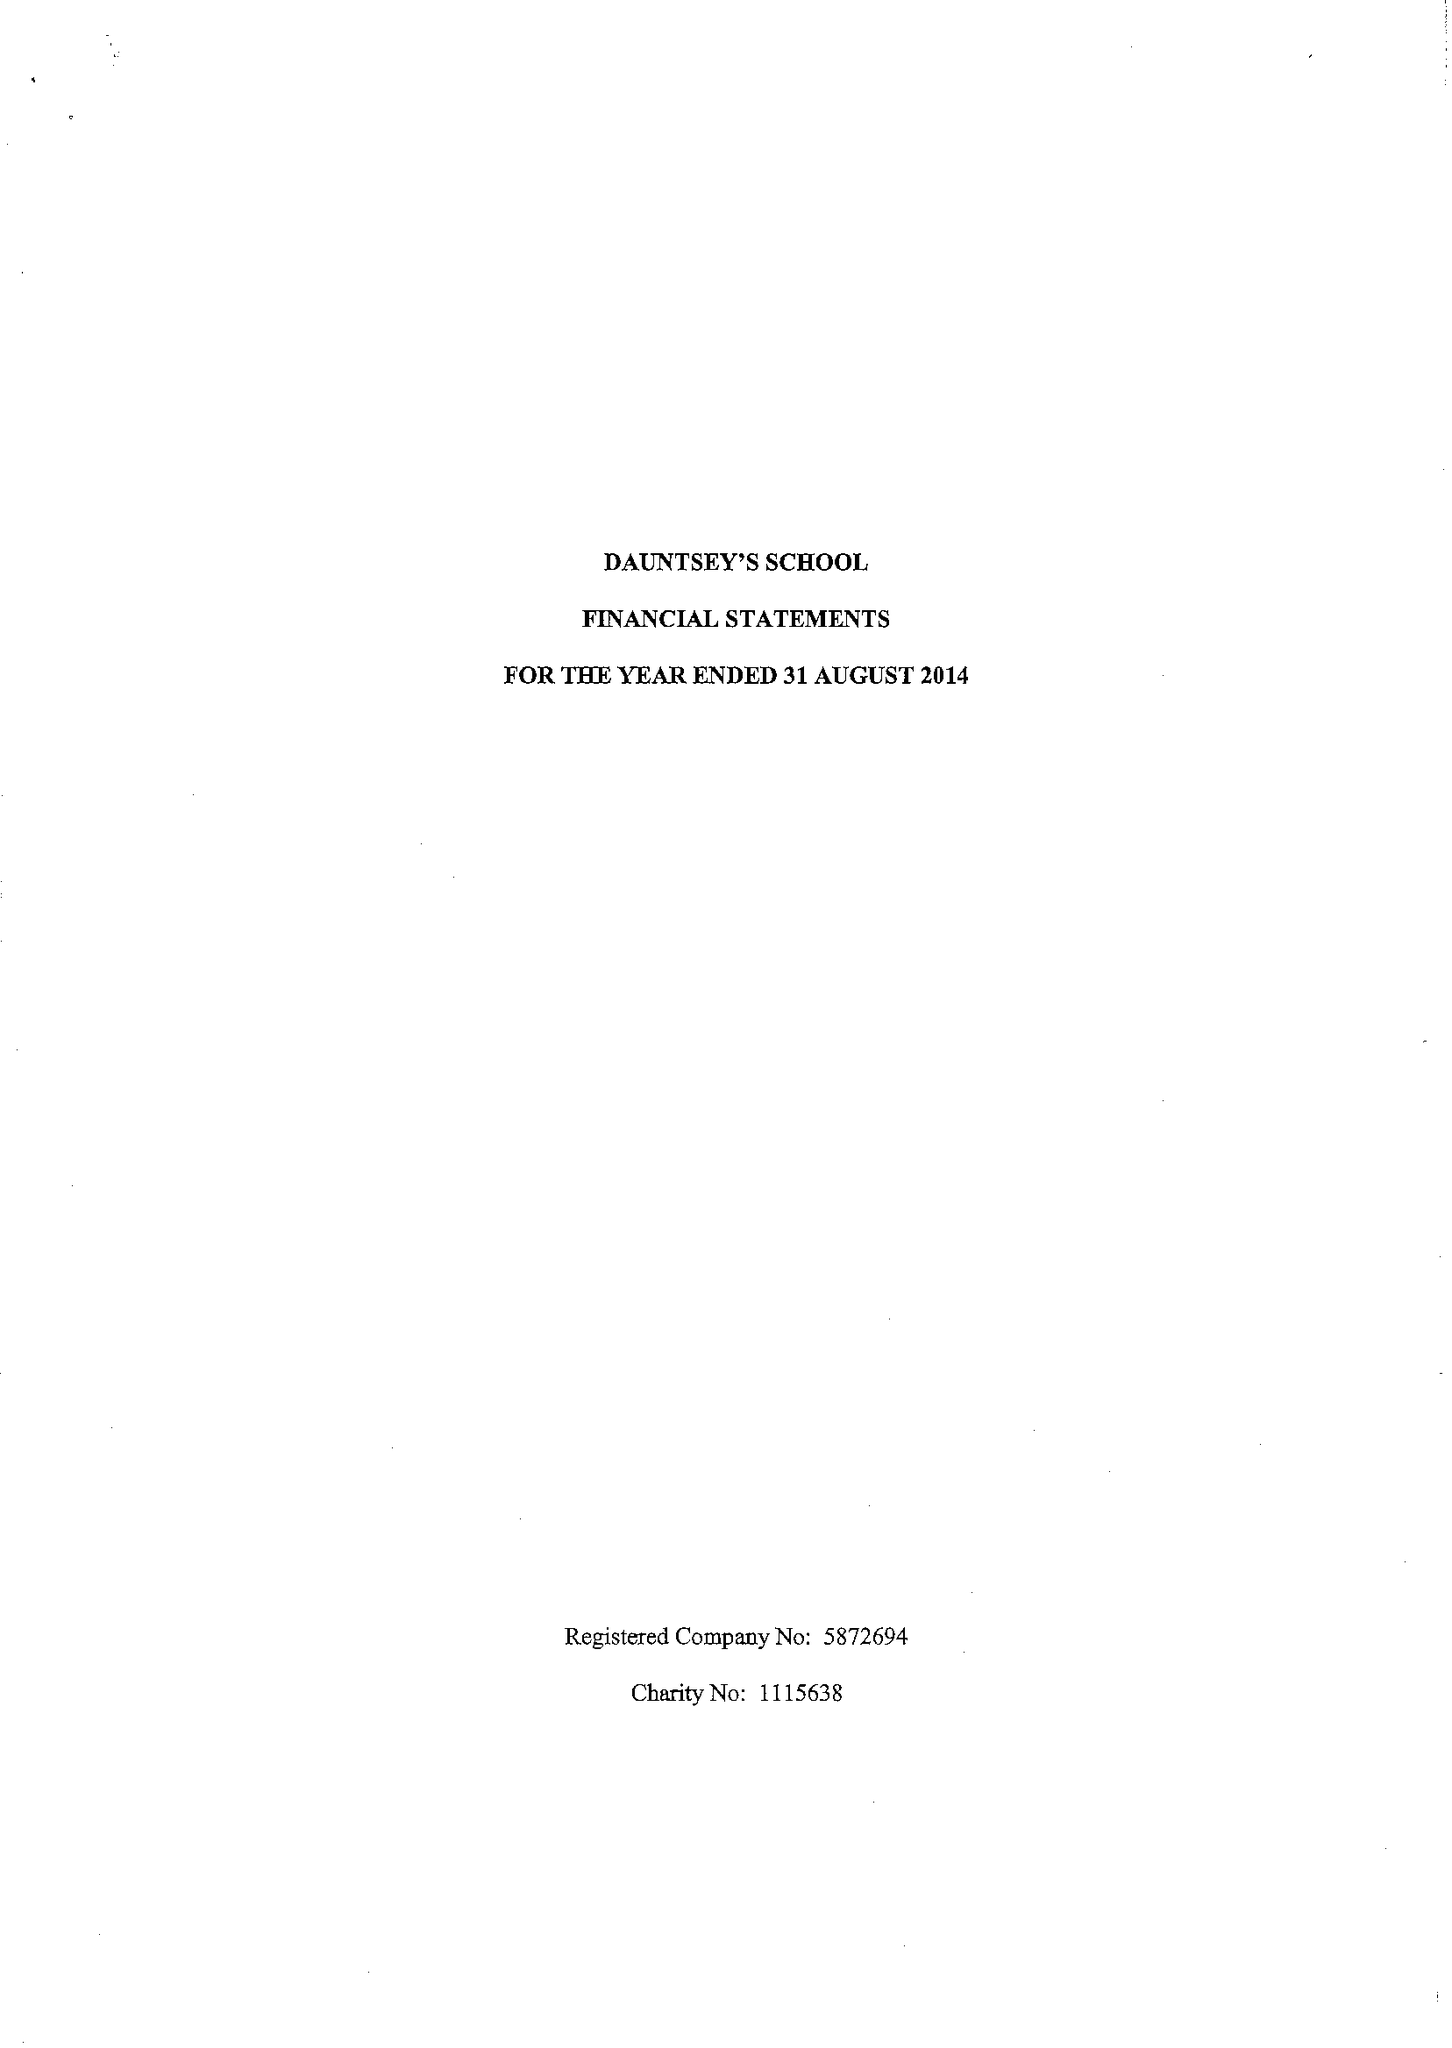What is the value for the report_date?
Answer the question using a single word or phrase. 2014-08-31 